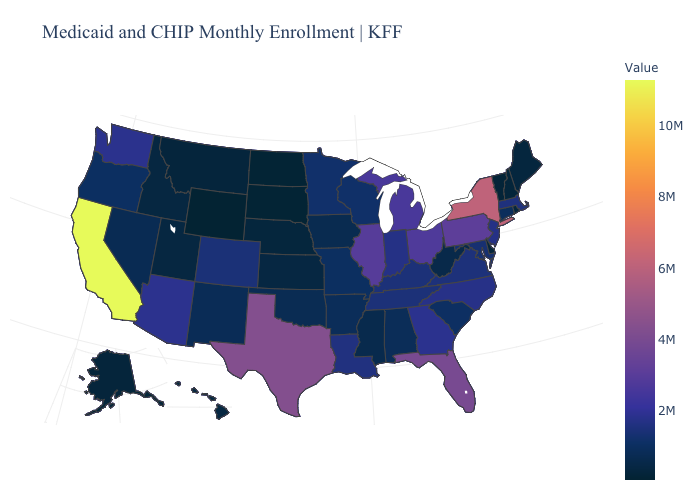Does Wyoming have the lowest value in the USA?
Short answer required. Yes. Among the states that border Kentucky , which have the highest value?
Be succinct. Illinois. Does Wyoming have the lowest value in the USA?
Quick response, please. Yes. 